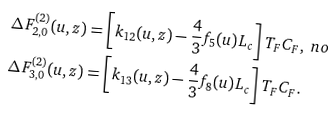<formula> <loc_0><loc_0><loc_500><loc_500>\Delta F _ { 2 , 0 } ^ { ( 2 ) } ( u , z ) & = \left [ k _ { 1 2 } ( u , z ) - \frac { 4 } { 3 } f _ { 5 } ( u ) L _ { c } \right ] T _ { F } C _ { F } , \ n o \\ \Delta F _ { 3 , 0 } ^ { ( 2 ) } ( u , z ) & = \left [ k _ { 1 3 } ( u , z ) - \frac { 4 } { 3 } f _ { 8 } ( u ) L _ { c } \right ] T _ { F } C _ { F } .</formula> 